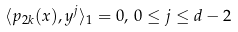<formula> <loc_0><loc_0><loc_500><loc_500>\langle p _ { 2 k } ( x ) , y ^ { j } \rangle _ { 1 } = 0 , \, 0 \leq j \leq d - 2</formula> 